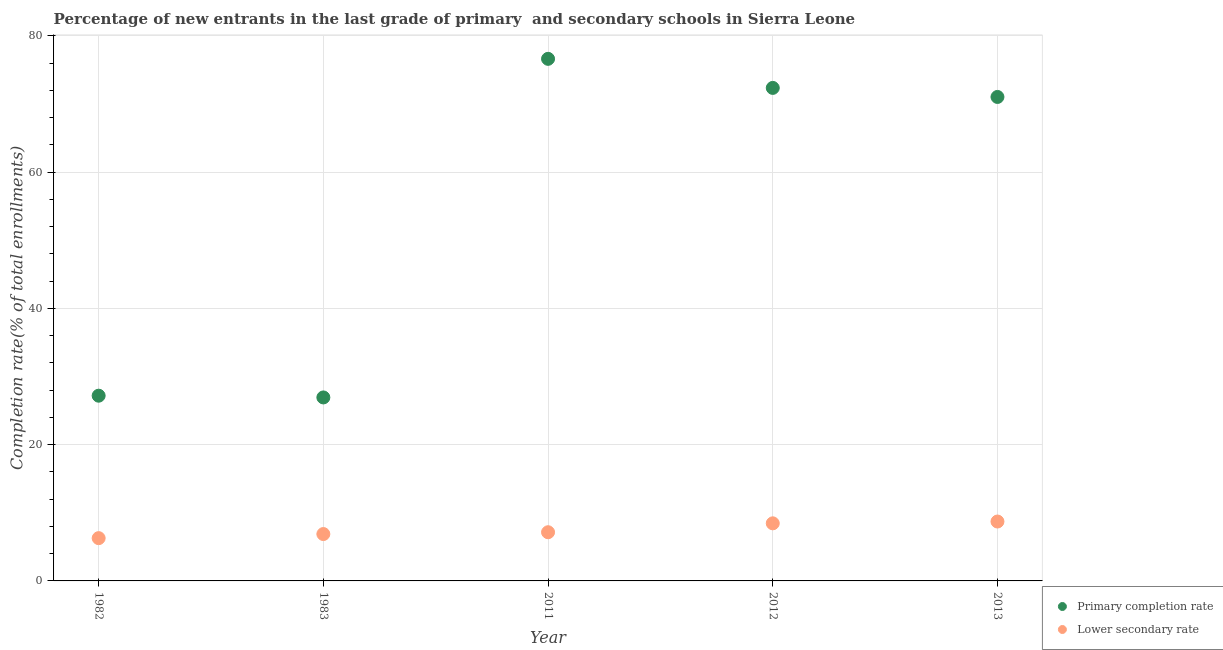How many different coloured dotlines are there?
Your response must be concise. 2. What is the completion rate in primary schools in 1982?
Offer a terse response. 27.18. Across all years, what is the maximum completion rate in primary schools?
Provide a short and direct response. 76.62. Across all years, what is the minimum completion rate in primary schools?
Keep it short and to the point. 26.93. In which year was the completion rate in primary schools minimum?
Make the answer very short. 1983. What is the total completion rate in primary schools in the graph?
Your response must be concise. 274.12. What is the difference between the completion rate in secondary schools in 1983 and that in 2011?
Offer a terse response. -0.27. What is the difference between the completion rate in primary schools in 1983 and the completion rate in secondary schools in 2013?
Your answer should be very brief. 18.21. What is the average completion rate in secondary schools per year?
Ensure brevity in your answer.  7.49. In the year 2013, what is the difference between the completion rate in secondary schools and completion rate in primary schools?
Your response must be concise. -62.31. In how many years, is the completion rate in secondary schools greater than 8 %?
Your answer should be very brief. 2. What is the ratio of the completion rate in primary schools in 2012 to that in 2013?
Offer a very short reply. 1.02. Is the difference between the completion rate in primary schools in 1983 and 2013 greater than the difference between the completion rate in secondary schools in 1983 and 2013?
Your answer should be very brief. No. What is the difference between the highest and the second highest completion rate in secondary schools?
Provide a succinct answer. 0.26. What is the difference between the highest and the lowest completion rate in primary schools?
Provide a short and direct response. 49.69. Is the sum of the completion rate in secondary schools in 1982 and 1983 greater than the maximum completion rate in primary schools across all years?
Offer a terse response. No. Is the completion rate in secondary schools strictly less than the completion rate in primary schools over the years?
Make the answer very short. Yes. How many years are there in the graph?
Make the answer very short. 5. What is the difference between two consecutive major ticks on the Y-axis?
Your answer should be very brief. 20. Does the graph contain grids?
Your answer should be very brief. Yes. Where does the legend appear in the graph?
Provide a succinct answer. Bottom right. What is the title of the graph?
Offer a very short reply. Percentage of new entrants in the last grade of primary  and secondary schools in Sierra Leone. Does "Methane" appear as one of the legend labels in the graph?
Your answer should be compact. No. What is the label or title of the X-axis?
Your response must be concise. Year. What is the label or title of the Y-axis?
Offer a very short reply. Completion rate(% of total enrollments). What is the Completion rate(% of total enrollments) of Primary completion rate in 1982?
Your answer should be compact. 27.18. What is the Completion rate(% of total enrollments) in Lower secondary rate in 1982?
Provide a short and direct response. 6.28. What is the Completion rate(% of total enrollments) in Primary completion rate in 1983?
Offer a terse response. 26.93. What is the Completion rate(% of total enrollments) in Lower secondary rate in 1983?
Give a very brief answer. 6.88. What is the Completion rate(% of total enrollments) in Primary completion rate in 2011?
Your answer should be compact. 76.62. What is the Completion rate(% of total enrollments) of Lower secondary rate in 2011?
Ensure brevity in your answer.  7.15. What is the Completion rate(% of total enrollments) in Primary completion rate in 2012?
Offer a terse response. 72.36. What is the Completion rate(% of total enrollments) in Lower secondary rate in 2012?
Provide a succinct answer. 8.45. What is the Completion rate(% of total enrollments) in Primary completion rate in 2013?
Make the answer very short. 71.03. What is the Completion rate(% of total enrollments) in Lower secondary rate in 2013?
Your answer should be compact. 8.72. Across all years, what is the maximum Completion rate(% of total enrollments) of Primary completion rate?
Give a very brief answer. 76.62. Across all years, what is the maximum Completion rate(% of total enrollments) of Lower secondary rate?
Provide a succinct answer. 8.72. Across all years, what is the minimum Completion rate(% of total enrollments) of Primary completion rate?
Make the answer very short. 26.93. Across all years, what is the minimum Completion rate(% of total enrollments) in Lower secondary rate?
Your answer should be very brief. 6.28. What is the total Completion rate(% of total enrollments) of Primary completion rate in the graph?
Offer a very short reply. 274.12. What is the total Completion rate(% of total enrollments) of Lower secondary rate in the graph?
Your answer should be compact. 37.47. What is the difference between the Completion rate(% of total enrollments) of Primary completion rate in 1982 and that in 1983?
Ensure brevity in your answer.  0.26. What is the difference between the Completion rate(% of total enrollments) in Lower secondary rate in 1982 and that in 1983?
Offer a very short reply. -0.6. What is the difference between the Completion rate(% of total enrollments) in Primary completion rate in 1982 and that in 2011?
Give a very brief answer. -49.44. What is the difference between the Completion rate(% of total enrollments) of Lower secondary rate in 1982 and that in 2011?
Your answer should be very brief. -0.87. What is the difference between the Completion rate(% of total enrollments) of Primary completion rate in 1982 and that in 2012?
Give a very brief answer. -45.17. What is the difference between the Completion rate(% of total enrollments) in Lower secondary rate in 1982 and that in 2012?
Give a very brief answer. -2.17. What is the difference between the Completion rate(% of total enrollments) in Primary completion rate in 1982 and that in 2013?
Give a very brief answer. -43.84. What is the difference between the Completion rate(% of total enrollments) in Lower secondary rate in 1982 and that in 2013?
Offer a very short reply. -2.44. What is the difference between the Completion rate(% of total enrollments) of Primary completion rate in 1983 and that in 2011?
Ensure brevity in your answer.  -49.69. What is the difference between the Completion rate(% of total enrollments) in Lower secondary rate in 1983 and that in 2011?
Offer a terse response. -0.27. What is the difference between the Completion rate(% of total enrollments) of Primary completion rate in 1983 and that in 2012?
Make the answer very short. -45.43. What is the difference between the Completion rate(% of total enrollments) in Lower secondary rate in 1983 and that in 2012?
Ensure brevity in your answer.  -1.57. What is the difference between the Completion rate(% of total enrollments) of Primary completion rate in 1983 and that in 2013?
Give a very brief answer. -44.1. What is the difference between the Completion rate(% of total enrollments) of Lower secondary rate in 1983 and that in 2013?
Your answer should be very brief. -1.84. What is the difference between the Completion rate(% of total enrollments) in Primary completion rate in 2011 and that in 2012?
Your answer should be compact. 4.27. What is the difference between the Completion rate(% of total enrollments) in Lower secondary rate in 2011 and that in 2012?
Offer a very short reply. -1.31. What is the difference between the Completion rate(% of total enrollments) in Primary completion rate in 2011 and that in 2013?
Offer a very short reply. 5.59. What is the difference between the Completion rate(% of total enrollments) of Lower secondary rate in 2011 and that in 2013?
Offer a very short reply. -1.57. What is the difference between the Completion rate(% of total enrollments) in Primary completion rate in 2012 and that in 2013?
Make the answer very short. 1.33. What is the difference between the Completion rate(% of total enrollments) of Lower secondary rate in 2012 and that in 2013?
Keep it short and to the point. -0.26. What is the difference between the Completion rate(% of total enrollments) of Primary completion rate in 1982 and the Completion rate(% of total enrollments) of Lower secondary rate in 1983?
Keep it short and to the point. 20.3. What is the difference between the Completion rate(% of total enrollments) in Primary completion rate in 1982 and the Completion rate(% of total enrollments) in Lower secondary rate in 2011?
Make the answer very short. 20.04. What is the difference between the Completion rate(% of total enrollments) in Primary completion rate in 1982 and the Completion rate(% of total enrollments) in Lower secondary rate in 2012?
Your answer should be very brief. 18.73. What is the difference between the Completion rate(% of total enrollments) in Primary completion rate in 1982 and the Completion rate(% of total enrollments) in Lower secondary rate in 2013?
Provide a short and direct response. 18.47. What is the difference between the Completion rate(% of total enrollments) in Primary completion rate in 1983 and the Completion rate(% of total enrollments) in Lower secondary rate in 2011?
Provide a succinct answer. 19.78. What is the difference between the Completion rate(% of total enrollments) of Primary completion rate in 1983 and the Completion rate(% of total enrollments) of Lower secondary rate in 2012?
Give a very brief answer. 18.48. What is the difference between the Completion rate(% of total enrollments) of Primary completion rate in 1983 and the Completion rate(% of total enrollments) of Lower secondary rate in 2013?
Ensure brevity in your answer.  18.21. What is the difference between the Completion rate(% of total enrollments) in Primary completion rate in 2011 and the Completion rate(% of total enrollments) in Lower secondary rate in 2012?
Provide a short and direct response. 68.17. What is the difference between the Completion rate(% of total enrollments) in Primary completion rate in 2011 and the Completion rate(% of total enrollments) in Lower secondary rate in 2013?
Offer a terse response. 67.9. What is the difference between the Completion rate(% of total enrollments) in Primary completion rate in 2012 and the Completion rate(% of total enrollments) in Lower secondary rate in 2013?
Ensure brevity in your answer.  63.64. What is the average Completion rate(% of total enrollments) in Primary completion rate per year?
Give a very brief answer. 54.82. What is the average Completion rate(% of total enrollments) in Lower secondary rate per year?
Provide a succinct answer. 7.49. In the year 1982, what is the difference between the Completion rate(% of total enrollments) of Primary completion rate and Completion rate(% of total enrollments) of Lower secondary rate?
Provide a succinct answer. 20.91. In the year 1983, what is the difference between the Completion rate(% of total enrollments) of Primary completion rate and Completion rate(% of total enrollments) of Lower secondary rate?
Ensure brevity in your answer.  20.05. In the year 2011, what is the difference between the Completion rate(% of total enrollments) of Primary completion rate and Completion rate(% of total enrollments) of Lower secondary rate?
Give a very brief answer. 69.48. In the year 2012, what is the difference between the Completion rate(% of total enrollments) in Primary completion rate and Completion rate(% of total enrollments) in Lower secondary rate?
Offer a very short reply. 63.9. In the year 2013, what is the difference between the Completion rate(% of total enrollments) of Primary completion rate and Completion rate(% of total enrollments) of Lower secondary rate?
Offer a very short reply. 62.31. What is the ratio of the Completion rate(% of total enrollments) of Primary completion rate in 1982 to that in 1983?
Your answer should be compact. 1.01. What is the ratio of the Completion rate(% of total enrollments) of Lower secondary rate in 1982 to that in 1983?
Keep it short and to the point. 0.91. What is the ratio of the Completion rate(% of total enrollments) of Primary completion rate in 1982 to that in 2011?
Keep it short and to the point. 0.35. What is the ratio of the Completion rate(% of total enrollments) in Lower secondary rate in 1982 to that in 2011?
Your answer should be very brief. 0.88. What is the ratio of the Completion rate(% of total enrollments) of Primary completion rate in 1982 to that in 2012?
Provide a short and direct response. 0.38. What is the ratio of the Completion rate(% of total enrollments) of Lower secondary rate in 1982 to that in 2012?
Your answer should be very brief. 0.74. What is the ratio of the Completion rate(% of total enrollments) of Primary completion rate in 1982 to that in 2013?
Your answer should be compact. 0.38. What is the ratio of the Completion rate(% of total enrollments) in Lower secondary rate in 1982 to that in 2013?
Keep it short and to the point. 0.72. What is the ratio of the Completion rate(% of total enrollments) in Primary completion rate in 1983 to that in 2011?
Your response must be concise. 0.35. What is the ratio of the Completion rate(% of total enrollments) of Lower secondary rate in 1983 to that in 2011?
Provide a succinct answer. 0.96. What is the ratio of the Completion rate(% of total enrollments) of Primary completion rate in 1983 to that in 2012?
Your answer should be compact. 0.37. What is the ratio of the Completion rate(% of total enrollments) of Lower secondary rate in 1983 to that in 2012?
Your answer should be very brief. 0.81. What is the ratio of the Completion rate(% of total enrollments) of Primary completion rate in 1983 to that in 2013?
Keep it short and to the point. 0.38. What is the ratio of the Completion rate(% of total enrollments) in Lower secondary rate in 1983 to that in 2013?
Make the answer very short. 0.79. What is the ratio of the Completion rate(% of total enrollments) of Primary completion rate in 2011 to that in 2012?
Your response must be concise. 1.06. What is the ratio of the Completion rate(% of total enrollments) in Lower secondary rate in 2011 to that in 2012?
Provide a short and direct response. 0.85. What is the ratio of the Completion rate(% of total enrollments) in Primary completion rate in 2011 to that in 2013?
Give a very brief answer. 1.08. What is the ratio of the Completion rate(% of total enrollments) of Lower secondary rate in 2011 to that in 2013?
Your answer should be compact. 0.82. What is the ratio of the Completion rate(% of total enrollments) of Primary completion rate in 2012 to that in 2013?
Provide a succinct answer. 1.02. What is the ratio of the Completion rate(% of total enrollments) of Lower secondary rate in 2012 to that in 2013?
Provide a short and direct response. 0.97. What is the difference between the highest and the second highest Completion rate(% of total enrollments) of Primary completion rate?
Offer a very short reply. 4.27. What is the difference between the highest and the second highest Completion rate(% of total enrollments) of Lower secondary rate?
Your answer should be compact. 0.26. What is the difference between the highest and the lowest Completion rate(% of total enrollments) in Primary completion rate?
Offer a terse response. 49.69. What is the difference between the highest and the lowest Completion rate(% of total enrollments) in Lower secondary rate?
Your answer should be compact. 2.44. 